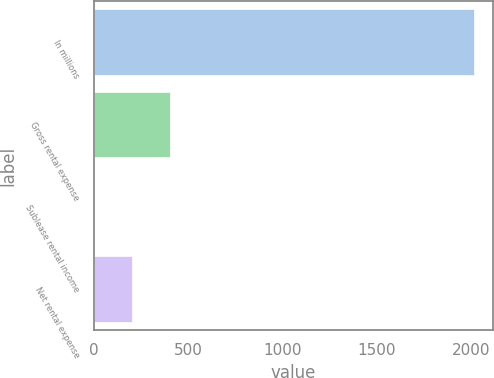Convert chart to OTSL. <chart><loc_0><loc_0><loc_500><loc_500><bar_chart><fcel>In millions<fcel>Gross rental expense<fcel>Sublease rental income<fcel>Net rental expense<nl><fcel>2014<fcel>403.84<fcel>1.3<fcel>202.57<nl></chart> 